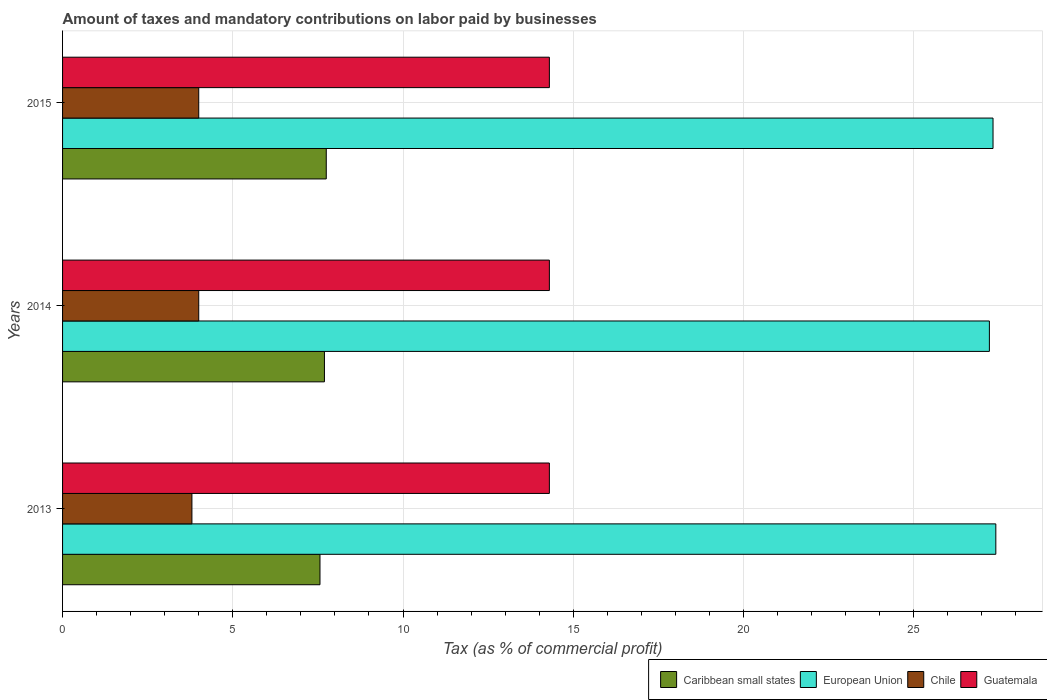Are the number of bars on each tick of the Y-axis equal?
Offer a very short reply. Yes. How many bars are there on the 2nd tick from the top?
Ensure brevity in your answer.  4. What is the label of the 1st group of bars from the top?
Ensure brevity in your answer.  2015. What is the total percentage of taxes paid by businesses in Guatemala in the graph?
Provide a short and direct response. 42.9. What is the difference between the percentage of taxes paid by businesses in European Union in 2013 and that in 2015?
Make the answer very short. 0.08. What is the difference between the percentage of taxes paid by businesses in European Union in 2014 and the percentage of taxes paid by businesses in Caribbean small states in 2013?
Give a very brief answer. 19.66. What is the average percentage of taxes paid by businesses in Guatemala per year?
Your response must be concise. 14.3. In the year 2015, what is the difference between the percentage of taxes paid by businesses in Chile and percentage of taxes paid by businesses in Caribbean small states?
Keep it short and to the point. -3.75. In how many years, is the percentage of taxes paid by businesses in European Union greater than 24 %?
Provide a short and direct response. 3. What is the ratio of the percentage of taxes paid by businesses in Chile in 2014 to that in 2015?
Give a very brief answer. 1. Is the difference between the percentage of taxes paid by businesses in Chile in 2014 and 2015 greater than the difference between the percentage of taxes paid by businesses in Caribbean small states in 2014 and 2015?
Give a very brief answer. Yes. What is the difference between the highest and the second highest percentage of taxes paid by businesses in European Union?
Your answer should be compact. 0.08. What is the difference between the highest and the lowest percentage of taxes paid by businesses in Guatemala?
Provide a succinct answer. 0. What does the 1st bar from the top in 2014 represents?
Give a very brief answer. Guatemala. How many bars are there?
Your answer should be compact. 12. Does the graph contain any zero values?
Offer a terse response. No. Where does the legend appear in the graph?
Keep it short and to the point. Bottom right. How are the legend labels stacked?
Your response must be concise. Horizontal. What is the title of the graph?
Provide a short and direct response. Amount of taxes and mandatory contributions on labor paid by businesses. Does "Hungary" appear as one of the legend labels in the graph?
Offer a very short reply. No. What is the label or title of the X-axis?
Your answer should be very brief. Tax (as % of commercial profit). What is the label or title of the Y-axis?
Your answer should be compact. Years. What is the Tax (as % of commercial profit) of Caribbean small states in 2013?
Offer a terse response. 7.56. What is the Tax (as % of commercial profit) in European Union in 2013?
Offer a terse response. 27.41. What is the Tax (as % of commercial profit) in Guatemala in 2013?
Offer a terse response. 14.3. What is the Tax (as % of commercial profit) of Caribbean small states in 2014?
Give a very brief answer. 7.69. What is the Tax (as % of commercial profit) in European Union in 2014?
Your answer should be very brief. 27.23. What is the Tax (as % of commercial profit) of Guatemala in 2014?
Your answer should be compact. 14.3. What is the Tax (as % of commercial profit) in Caribbean small states in 2015?
Provide a short and direct response. 7.75. What is the Tax (as % of commercial profit) in European Union in 2015?
Your answer should be very brief. 27.33. What is the Tax (as % of commercial profit) in Chile in 2015?
Give a very brief answer. 4. What is the Tax (as % of commercial profit) of Guatemala in 2015?
Ensure brevity in your answer.  14.3. Across all years, what is the maximum Tax (as % of commercial profit) in Caribbean small states?
Give a very brief answer. 7.75. Across all years, what is the maximum Tax (as % of commercial profit) of European Union?
Give a very brief answer. 27.41. Across all years, what is the maximum Tax (as % of commercial profit) of Chile?
Offer a terse response. 4. Across all years, what is the maximum Tax (as % of commercial profit) of Guatemala?
Your answer should be very brief. 14.3. Across all years, what is the minimum Tax (as % of commercial profit) in Caribbean small states?
Your answer should be very brief. 7.56. Across all years, what is the minimum Tax (as % of commercial profit) in European Union?
Ensure brevity in your answer.  27.23. Across all years, what is the minimum Tax (as % of commercial profit) of Chile?
Make the answer very short. 3.8. What is the total Tax (as % of commercial profit) in European Union in the graph?
Make the answer very short. 81.97. What is the total Tax (as % of commercial profit) in Guatemala in the graph?
Offer a terse response. 42.9. What is the difference between the Tax (as % of commercial profit) of Caribbean small states in 2013 and that in 2014?
Your answer should be very brief. -0.13. What is the difference between the Tax (as % of commercial profit) of European Union in 2013 and that in 2014?
Your answer should be very brief. 0.19. What is the difference between the Tax (as % of commercial profit) in Caribbean small states in 2013 and that in 2015?
Provide a succinct answer. -0.18. What is the difference between the Tax (as % of commercial profit) in European Union in 2013 and that in 2015?
Provide a short and direct response. 0.08. What is the difference between the Tax (as % of commercial profit) in Chile in 2013 and that in 2015?
Make the answer very short. -0.2. What is the difference between the Tax (as % of commercial profit) in Caribbean small states in 2014 and that in 2015?
Make the answer very short. -0.05. What is the difference between the Tax (as % of commercial profit) of European Union in 2014 and that in 2015?
Offer a terse response. -0.11. What is the difference between the Tax (as % of commercial profit) in Chile in 2014 and that in 2015?
Ensure brevity in your answer.  0. What is the difference between the Tax (as % of commercial profit) in Guatemala in 2014 and that in 2015?
Provide a short and direct response. 0. What is the difference between the Tax (as % of commercial profit) of Caribbean small states in 2013 and the Tax (as % of commercial profit) of European Union in 2014?
Offer a terse response. -19.66. What is the difference between the Tax (as % of commercial profit) in Caribbean small states in 2013 and the Tax (as % of commercial profit) in Chile in 2014?
Your response must be concise. 3.56. What is the difference between the Tax (as % of commercial profit) of Caribbean small states in 2013 and the Tax (as % of commercial profit) of Guatemala in 2014?
Give a very brief answer. -6.74. What is the difference between the Tax (as % of commercial profit) in European Union in 2013 and the Tax (as % of commercial profit) in Chile in 2014?
Provide a succinct answer. 23.41. What is the difference between the Tax (as % of commercial profit) in European Union in 2013 and the Tax (as % of commercial profit) in Guatemala in 2014?
Keep it short and to the point. 13.11. What is the difference between the Tax (as % of commercial profit) of Chile in 2013 and the Tax (as % of commercial profit) of Guatemala in 2014?
Provide a short and direct response. -10.5. What is the difference between the Tax (as % of commercial profit) in Caribbean small states in 2013 and the Tax (as % of commercial profit) in European Union in 2015?
Your answer should be compact. -19.77. What is the difference between the Tax (as % of commercial profit) of Caribbean small states in 2013 and the Tax (as % of commercial profit) of Chile in 2015?
Offer a very short reply. 3.56. What is the difference between the Tax (as % of commercial profit) in Caribbean small states in 2013 and the Tax (as % of commercial profit) in Guatemala in 2015?
Your response must be concise. -6.74. What is the difference between the Tax (as % of commercial profit) in European Union in 2013 and the Tax (as % of commercial profit) in Chile in 2015?
Give a very brief answer. 23.41. What is the difference between the Tax (as % of commercial profit) in European Union in 2013 and the Tax (as % of commercial profit) in Guatemala in 2015?
Your answer should be very brief. 13.11. What is the difference between the Tax (as % of commercial profit) in Caribbean small states in 2014 and the Tax (as % of commercial profit) in European Union in 2015?
Ensure brevity in your answer.  -19.64. What is the difference between the Tax (as % of commercial profit) in Caribbean small states in 2014 and the Tax (as % of commercial profit) in Chile in 2015?
Provide a short and direct response. 3.69. What is the difference between the Tax (as % of commercial profit) in Caribbean small states in 2014 and the Tax (as % of commercial profit) in Guatemala in 2015?
Give a very brief answer. -6.61. What is the difference between the Tax (as % of commercial profit) in European Union in 2014 and the Tax (as % of commercial profit) in Chile in 2015?
Your answer should be very brief. 23.23. What is the difference between the Tax (as % of commercial profit) of European Union in 2014 and the Tax (as % of commercial profit) of Guatemala in 2015?
Your response must be concise. 12.93. What is the difference between the Tax (as % of commercial profit) of Chile in 2014 and the Tax (as % of commercial profit) of Guatemala in 2015?
Ensure brevity in your answer.  -10.3. What is the average Tax (as % of commercial profit) of Caribbean small states per year?
Provide a short and direct response. 7.67. What is the average Tax (as % of commercial profit) in European Union per year?
Provide a short and direct response. 27.32. What is the average Tax (as % of commercial profit) of Chile per year?
Provide a succinct answer. 3.93. In the year 2013, what is the difference between the Tax (as % of commercial profit) in Caribbean small states and Tax (as % of commercial profit) in European Union?
Your answer should be compact. -19.85. In the year 2013, what is the difference between the Tax (as % of commercial profit) in Caribbean small states and Tax (as % of commercial profit) in Chile?
Your answer should be very brief. 3.76. In the year 2013, what is the difference between the Tax (as % of commercial profit) of Caribbean small states and Tax (as % of commercial profit) of Guatemala?
Give a very brief answer. -6.74. In the year 2013, what is the difference between the Tax (as % of commercial profit) of European Union and Tax (as % of commercial profit) of Chile?
Offer a very short reply. 23.61. In the year 2013, what is the difference between the Tax (as % of commercial profit) of European Union and Tax (as % of commercial profit) of Guatemala?
Your answer should be very brief. 13.11. In the year 2013, what is the difference between the Tax (as % of commercial profit) of Chile and Tax (as % of commercial profit) of Guatemala?
Keep it short and to the point. -10.5. In the year 2014, what is the difference between the Tax (as % of commercial profit) in Caribbean small states and Tax (as % of commercial profit) in European Union?
Give a very brief answer. -19.53. In the year 2014, what is the difference between the Tax (as % of commercial profit) in Caribbean small states and Tax (as % of commercial profit) in Chile?
Give a very brief answer. 3.69. In the year 2014, what is the difference between the Tax (as % of commercial profit) of Caribbean small states and Tax (as % of commercial profit) of Guatemala?
Your answer should be compact. -6.61. In the year 2014, what is the difference between the Tax (as % of commercial profit) in European Union and Tax (as % of commercial profit) in Chile?
Provide a succinct answer. 23.23. In the year 2014, what is the difference between the Tax (as % of commercial profit) of European Union and Tax (as % of commercial profit) of Guatemala?
Your answer should be compact. 12.93. In the year 2015, what is the difference between the Tax (as % of commercial profit) in Caribbean small states and Tax (as % of commercial profit) in European Union?
Offer a very short reply. -19.59. In the year 2015, what is the difference between the Tax (as % of commercial profit) in Caribbean small states and Tax (as % of commercial profit) in Chile?
Your answer should be very brief. 3.75. In the year 2015, what is the difference between the Tax (as % of commercial profit) of Caribbean small states and Tax (as % of commercial profit) of Guatemala?
Offer a very short reply. -6.55. In the year 2015, what is the difference between the Tax (as % of commercial profit) of European Union and Tax (as % of commercial profit) of Chile?
Give a very brief answer. 23.33. In the year 2015, what is the difference between the Tax (as % of commercial profit) in European Union and Tax (as % of commercial profit) in Guatemala?
Your answer should be very brief. 13.03. What is the ratio of the Tax (as % of commercial profit) in Caribbean small states in 2013 to that in 2014?
Give a very brief answer. 0.98. What is the ratio of the Tax (as % of commercial profit) of European Union in 2013 to that in 2014?
Ensure brevity in your answer.  1.01. What is the ratio of the Tax (as % of commercial profit) in Chile in 2013 to that in 2014?
Offer a terse response. 0.95. What is the ratio of the Tax (as % of commercial profit) of Guatemala in 2013 to that in 2014?
Your answer should be compact. 1. What is the ratio of the Tax (as % of commercial profit) of Caribbean small states in 2013 to that in 2015?
Offer a terse response. 0.98. What is the ratio of the Tax (as % of commercial profit) of European Union in 2014 to that in 2015?
Provide a short and direct response. 1. What is the ratio of the Tax (as % of commercial profit) of Chile in 2014 to that in 2015?
Offer a very short reply. 1. What is the ratio of the Tax (as % of commercial profit) of Guatemala in 2014 to that in 2015?
Provide a succinct answer. 1. What is the difference between the highest and the second highest Tax (as % of commercial profit) of Caribbean small states?
Provide a short and direct response. 0.05. What is the difference between the highest and the second highest Tax (as % of commercial profit) of European Union?
Provide a succinct answer. 0.08. What is the difference between the highest and the lowest Tax (as % of commercial profit) in Caribbean small states?
Offer a terse response. 0.18. What is the difference between the highest and the lowest Tax (as % of commercial profit) in European Union?
Make the answer very short. 0.19. What is the difference between the highest and the lowest Tax (as % of commercial profit) of Chile?
Make the answer very short. 0.2. 